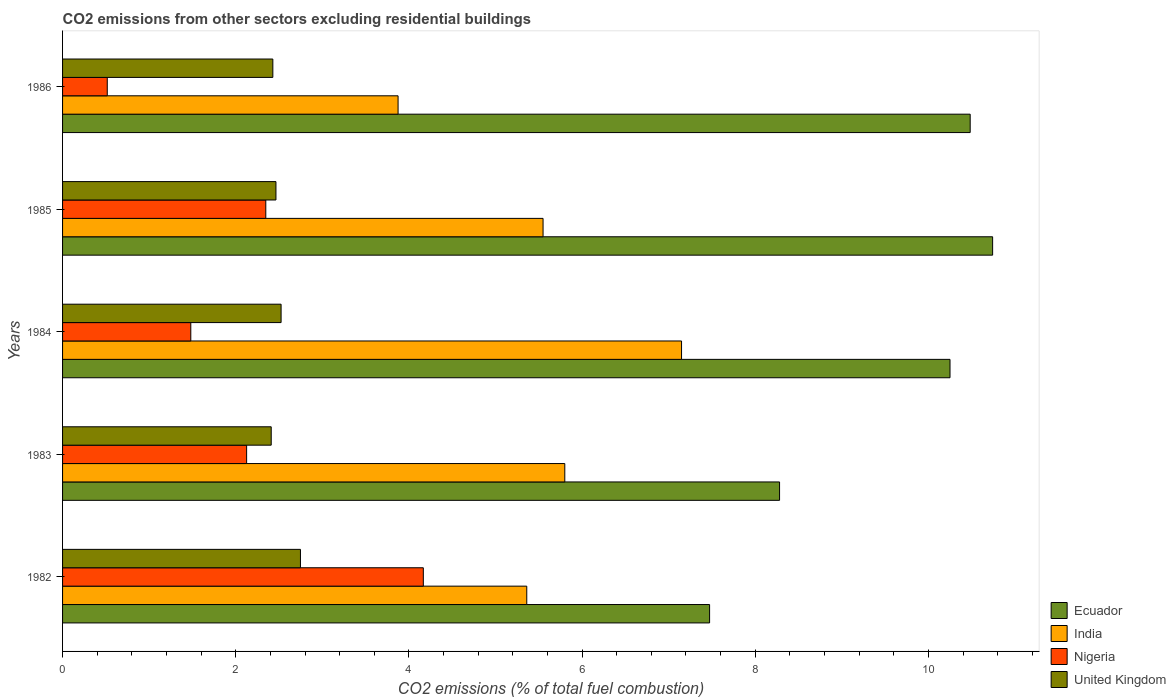How many groups of bars are there?
Offer a very short reply. 5. Are the number of bars per tick equal to the number of legend labels?
Give a very brief answer. Yes. In how many cases, is the number of bars for a given year not equal to the number of legend labels?
Ensure brevity in your answer.  0. What is the total CO2 emitted in United Kingdom in 1986?
Offer a very short reply. 2.43. Across all years, what is the maximum total CO2 emitted in Nigeria?
Offer a very short reply. 4.17. Across all years, what is the minimum total CO2 emitted in Ecuador?
Provide a succinct answer. 7.47. In which year was the total CO2 emitted in Ecuador minimum?
Offer a very short reply. 1982. What is the total total CO2 emitted in United Kingdom in the graph?
Make the answer very short. 12.57. What is the difference between the total CO2 emitted in India in 1983 and that in 1985?
Make the answer very short. 0.25. What is the difference between the total CO2 emitted in Nigeria in 1985 and the total CO2 emitted in India in 1984?
Your answer should be compact. -4.8. What is the average total CO2 emitted in Nigeria per year?
Provide a short and direct response. 2.13. In the year 1985, what is the difference between the total CO2 emitted in Ecuador and total CO2 emitted in India?
Offer a terse response. 5.19. What is the ratio of the total CO2 emitted in Ecuador in 1982 to that in 1986?
Your response must be concise. 0.71. Is the difference between the total CO2 emitted in Ecuador in 1984 and 1986 greater than the difference between the total CO2 emitted in India in 1984 and 1986?
Make the answer very short. No. What is the difference between the highest and the second highest total CO2 emitted in India?
Your answer should be compact. 1.35. What is the difference between the highest and the lowest total CO2 emitted in United Kingdom?
Provide a succinct answer. 0.34. Is the sum of the total CO2 emitted in Ecuador in 1982 and 1984 greater than the maximum total CO2 emitted in India across all years?
Your answer should be very brief. Yes. Is it the case that in every year, the sum of the total CO2 emitted in Ecuador and total CO2 emitted in United Kingdom is greater than the sum of total CO2 emitted in Nigeria and total CO2 emitted in India?
Offer a terse response. No. What does the 3rd bar from the bottom in 1985 represents?
Your answer should be very brief. Nigeria. Is it the case that in every year, the sum of the total CO2 emitted in India and total CO2 emitted in Ecuador is greater than the total CO2 emitted in Nigeria?
Offer a terse response. Yes. How many bars are there?
Your answer should be very brief. 20. Are all the bars in the graph horizontal?
Offer a very short reply. Yes. Does the graph contain any zero values?
Provide a short and direct response. No. Does the graph contain grids?
Offer a terse response. No. Where does the legend appear in the graph?
Provide a succinct answer. Bottom right. How many legend labels are there?
Offer a terse response. 4. How are the legend labels stacked?
Offer a very short reply. Vertical. What is the title of the graph?
Make the answer very short. CO2 emissions from other sectors excluding residential buildings. Does "Korea (Democratic)" appear as one of the legend labels in the graph?
Your answer should be very brief. No. What is the label or title of the X-axis?
Give a very brief answer. CO2 emissions (% of total fuel combustion). What is the CO2 emissions (% of total fuel combustion) of Ecuador in 1982?
Provide a succinct answer. 7.47. What is the CO2 emissions (% of total fuel combustion) of India in 1982?
Your answer should be very brief. 5.36. What is the CO2 emissions (% of total fuel combustion) in Nigeria in 1982?
Offer a terse response. 4.17. What is the CO2 emissions (% of total fuel combustion) of United Kingdom in 1982?
Your answer should be compact. 2.75. What is the CO2 emissions (% of total fuel combustion) of Ecuador in 1983?
Provide a short and direct response. 8.28. What is the CO2 emissions (% of total fuel combustion) of India in 1983?
Make the answer very short. 5.8. What is the CO2 emissions (% of total fuel combustion) of Nigeria in 1983?
Keep it short and to the point. 2.13. What is the CO2 emissions (% of total fuel combustion) of United Kingdom in 1983?
Ensure brevity in your answer.  2.41. What is the CO2 emissions (% of total fuel combustion) of Ecuador in 1984?
Your answer should be very brief. 10.25. What is the CO2 emissions (% of total fuel combustion) of India in 1984?
Offer a very short reply. 7.15. What is the CO2 emissions (% of total fuel combustion) of Nigeria in 1984?
Provide a succinct answer. 1.48. What is the CO2 emissions (% of total fuel combustion) of United Kingdom in 1984?
Keep it short and to the point. 2.52. What is the CO2 emissions (% of total fuel combustion) in Ecuador in 1985?
Your answer should be compact. 10.74. What is the CO2 emissions (% of total fuel combustion) of India in 1985?
Your response must be concise. 5.55. What is the CO2 emissions (% of total fuel combustion) in Nigeria in 1985?
Your response must be concise. 2.35. What is the CO2 emissions (% of total fuel combustion) in United Kingdom in 1985?
Your answer should be very brief. 2.46. What is the CO2 emissions (% of total fuel combustion) of Ecuador in 1986?
Give a very brief answer. 10.48. What is the CO2 emissions (% of total fuel combustion) of India in 1986?
Make the answer very short. 3.88. What is the CO2 emissions (% of total fuel combustion) of Nigeria in 1986?
Keep it short and to the point. 0.52. What is the CO2 emissions (% of total fuel combustion) in United Kingdom in 1986?
Make the answer very short. 2.43. Across all years, what is the maximum CO2 emissions (% of total fuel combustion) of Ecuador?
Your answer should be very brief. 10.74. Across all years, what is the maximum CO2 emissions (% of total fuel combustion) of India?
Make the answer very short. 7.15. Across all years, what is the maximum CO2 emissions (% of total fuel combustion) in Nigeria?
Your answer should be compact. 4.17. Across all years, what is the maximum CO2 emissions (% of total fuel combustion) in United Kingdom?
Give a very brief answer. 2.75. Across all years, what is the minimum CO2 emissions (% of total fuel combustion) in Ecuador?
Ensure brevity in your answer.  7.47. Across all years, what is the minimum CO2 emissions (% of total fuel combustion) of India?
Your answer should be compact. 3.88. Across all years, what is the minimum CO2 emissions (% of total fuel combustion) of Nigeria?
Ensure brevity in your answer.  0.52. Across all years, what is the minimum CO2 emissions (% of total fuel combustion) of United Kingdom?
Offer a terse response. 2.41. What is the total CO2 emissions (% of total fuel combustion) in Ecuador in the graph?
Offer a terse response. 47.23. What is the total CO2 emissions (% of total fuel combustion) in India in the graph?
Your response must be concise. 27.73. What is the total CO2 emissions (% of total fuel combustion) of Nigeria in the graph?
Offer a very short reply. 10.64. What is the total CO2 emissions (% of total fuel combustion) in United Kingdom in the graph?
Your answer should be very brief. 12.57. What is the difference between the CO2 emissions (% of total fuel combustion) in Ecuador in 1982 and that in 1983?
Offer a terse response. -0.81. What is the difference between the CO2 emissions (% of total fuel combustion) in India in 1982 and that in 1983?
Offer a very short reply. -0.44. What is the difference between the CO2 emissions (% of total fuel combustion) of Nigeria in 1982 and that in 1983?
Your answer should be compact. 2.04. What is the difference between the CO2 emissions (% of total fuel combustion) of United Kingdom in 1982 and that in 1983?
Your response must be concise. 0.34. What is the difference between the CO2 emissions (% of total fuel combustion) of Ecuador in 1982 and that in 1984?
Offer a very short reply. -2.78. What is the difference between the CO2 emissions (% of total fuel combustion) in India in 1982 and that in 1984?
Ensure brevity in your answer.  -1.79. What is the difference between the CO2 emissions (% of total fuel combustion) in Nigeria in 1982 and that in 1984?
Ensure brevity in your answer.  2.69. What is the difference between the CO2 emissions (% of total fuel combustion) of United Kingdom in 1982 and that in 1984?
Your answer should be very brief. 0.22. What is the difference between the CO2 emissions (% of total fuel combustion) in Ecuador in 1982 and that in 1985?
Give a very brief answer. -3.27. What is the difference between the CO2 emissions (% of total fuel combustion) in India in 1982 and that in 1985?
Offer a very short reply. -0.19. What is the difference between the CO2 emissions (% of total fuel combustion) of Nigeria in 1982 and that in 1985?
Your answer should be compact. 1.82. What is the difference between the CO2 emissions (% of total fuel combustion) in United Kingdom in 1982 and that in 1985?
Keep it short and to the point. 0.28. What is the difference between the CO2 emissions (% of total fuel combustion) of Ecuador in 1982 and that in 1986?
Keep it short and to the point. -3.01. What is the difference between the CO2 emissions (% of total fuel combustion) in India in 1982 and that in 1986?
Offer a very short reply. 1.49. What is the difference between the CO2 emissions (% of total fuel combustion) in Nigeria in 1982 and that in 1986?
Provide a short and direct response. 3.65. What is the difference between the CO2 emissions (% of total fuel combustion) of United Kingdom in 1982 and that in 1986?
Give a very brief answer. 0.32. What is the difference between the CO2 emissions (% of total fuel combustion) of Ecuador in 1983 and that in 1984?
Your answer should be very brief. -1.97. What is the difference between the CO2 emissions (% of total fuel combustion) of India in 1983 and that in 1984?
Ensure brevity in your answer.  -1.35. What is the difference between the CO2 emissions (% of total fuel combustion) in Nigeria in 1983 and that in 1984?
Offer a very short reply. 0.64. What is the difference between the CO2 emissions (% of total fuel combustion) in United Kingdom in 1983 and that in 1984?
Offer a very short reply. -0.11. What is the difference between the CO2 emissions (% of total fuel combustion) in Ecuador in 1983 and that in 1985?
Keep it short and to the point. -2.46. What is the difference between the CO2 emissions (% of total fuel combustion) in India in 1983 and that in 1985?
Provide a short and direct response. 0.25. What is the difference between the CO2 emissions (% of total fuel combustion) of Nigeria in 1983 and that in 1985?
Your response must be concise. -0.22. What is the difference between the CO2 emissions (% of total fuel combustion) in United Kingdom in 1983 and that in 1985?
Your answer should be compact. -0.05. What is the difference between the CO2 emissions (% of total fuel combustion) of Ecuador in 1983 and that in 1986?
Give a very brief answer. -2.2. What is the difference between the CO2 emissions (% of total fuel combustion) of India in 1983 and that in 1986?
Your response must be concise. 1.93. What is the difference between the CO2 emissions (% of total fuel combustion) of Nigeria in 1983 and that in 1986?
Make the answer very short. 1.61. What is the difference between the CO2 emissions (% of total fuel combustion) of United Kingdom in 1983 and that in 1986?
Your response must be concise. -0.02. What is the difference between the CO2 emissions (% of total fuel combustion) in Ecuador in 1984 and that in 1985?
Provide a succinct answer. -0.49. What is the difference between the CO2 emissions (% of total fuel combustion) in India in 1984 and that in 1985?
Keep it short and to the point. 1.6. What is the difference between the CO2 emissions (% of total fuel combustion) in Nigeria in 1984 and that in 1985?
Your answer should be compact. -0.87. What is the difference between the CO2 emissions (% of total fuel combustion) of United Kingdom in 1984 and that in 1985?
Give a very brief answer. 0.06. What is the difference between the CO2 emissions (% of total fuel combustion) of Ecuador in 1984 and that in 1986?
Ensure brevity in your answer.  -0.23. What is the difference between the CO2 emissions (% of total fuel combustion) of India in 1984 and that in 1986?
Provide a short and direct response. 3.27. What is the difference between the CO2 emissions (% of total fuel combustion) in Nigeria in 1984 and that in 1986?
Ensure brevity in your answer.  0.96. What is the difference between the CO2 emissions (% of total fuel combustion) of United Kingdom in 1984 and that in 1986?
Your answer should be compact. 0.1. What is the difference between the CO2 emissions (% of total fuel combustion) in Ecuador in 1985 and that in 1986?
Keep it short and to the point. 0.26. What is the difference between the CO2 emissions (% of total fuel combustion) in India in 1985 and that in 1986?
Your answer should be compact. 1.67. What is the difference between the CO2 emissions (% of total fuel combustion) in Nigeria in 1985 and that in 1986?
Offer a terse response. 1.83. What is the difference between the CO2 emissions (% of total fuel combustion) of United Kingdom in 1985 and that in 1986?
Give a very brief answer. 0.04. What is the difference between the CO2 emissions (% of total fuel combustion) in Ecuador in 1982 and the CO2 emissions (% of total fuel combustion) in India in 1983?
Keep it short and to the point. 1.67. What is the difference between the CO2 emissions (% of total fuel combustion) of Ecuador in 1982 and the CO2 emissions (% of total fuel combustion) of Nigeria in 1983?
Provide a succinct answer. 5.35. What is the difference between the CO2 emissions (% of total fuel combustion) of Ecuador in 1982 and the CO2 emissions (% of total fuel combustion) of United Kingdom in 1983?
Keep it short and to the point. 5.06. What is the difference between the CO2 emissions (% of total fuel combustion) of India in 1982 and the CO2 emissions (% of total fuel combustion) of Nigeria in 1983?
Keep it short and to the point. 3.24. What is the difference between the CO2 emissions (% of total fuel combustion) in India in 1982 and the CO2 emissions (% of total fuel combustion) in United Kingdom in 1983?
Provide a short and direct response. 2.95. What is the difference between the CO2 emissions (% of total fuel combustion) of Nigeria in 1982 and the CO2 emissions (% of total fuel combustion) of United Kingdom in 1983?
Offer a terse response. 1.76. What is the difference between the CO2 emissions (% of total fuel combustion) of Ecuador in 1982 and the CO2 emissions (% of total fuel combustion) of India in 1984?
Give a very brief answer. 0.32. What is the difference between the CO2 emissions (% of total fuel combustion) of Ecuador in 1982 and the CO2 emissions (% of total fuel combustion) of Nigeria in 1984?
Your response must be concise. 5.99. What is the difference between the CO2 emissions (% of total fuel combustion) in Ecuador in 1982 and the CO2 emissions (% of total fuel combustion) in United Kingdom in 1984?
Keep it short and to the point. 4.95. What is the difference between the CO2 emissions (% of total fuel combustion) of India in 1982 and the CO2 emissions (% of total fuel combustion) of Nigeria in 1984?
Your answer should be very brief. 3.88. What is the difference between the CO2 emissions (% of total fuel combustion) of India in 1982 and the CO2 emissions (% of total fuel combustion) of United Kingdom in 1984?
Give a very brief answer. 2.84. What is the difference between the CO2 emissions (% of total fuel combustion) in Nigeria in 1982 and the CO2 emissions (% of total fuel combustion) in United Kingdom in 1984?
Offer a very short reply. 1.64. What is the difference between the CO2 emissions (% of total fuel combustion) in Ecuador in 1982 and the CO2 emissions (% of total fuel combustion) in India in 1985?
Offer a terse response. 1.92. What is the difference between the CO2 emissions (% of total fuel combustion) of Ecuador in 1982 and the CO2 emissions (% of total fuel combustion) of Nigeria in 1985?
Your response must be concise. 5.13. What is the difference between the CO2 emissions (% of total fuel combustion) of Ecuador in 1982 and the CO2 emissions (% of total fuel combustion) of United Kingdom in 1985?
Give a very brief answer. 5.01. What is the difference between the CO2 emissions (% of total fuel combustion) in India in 1982 and the CO2 emissions (% of total fuel combustion) in Nigeria in 1985?
Your response must be concise. 3.01. What is the difference between the CO2 emissions (% of total fuel combustion) of India in 1982 and the CO2 emissions (% of total fuel combustion) of United Kingdom in 1985?
Offer a terse response. 2.9. What is the difference between the CO2 emissions (% of total fuel combustion) of Nigeria in 1982 and the CO2 emissions (% of total fuel combustion) of United Kingdom in 1985?
Make the answer very short. 1.7. What is the difference between the CO2 emissions (% of total fuel combustion) in Ecuador in 1982 and the CO2 emissions (% of total fuel combustion) in India in 1986?
Give a very brief answer. 3.6. What is the difference between the CO2 emissions (% of total fuel combustion) of Ecuador in 1982 and the CO2 emissions (% of total fuel combustion) of Nigeria in 1986?
Provide a short and direct response. 6.96. What is the difference between the CO2 emissions (% of total fuel combustion) in Ecuador in 1982 and the CO2 emissions (% of total fuel combustion) in United Kingdom in 1986?
Ensure brevity in your answer.  5.04. What is the difference between the CO2 emissions (% of total fuel combustion) of India in 1982 and the CO2 emissions (% of total fuel combustion) of Nigeria in 1986?
Offer a terse response. 4.84. What is the difference between the CO2 emissions (% of total fuel combustion) in India in 1982 and the CO2 emissions (% of total fuel combustion) in United Kingdom in 1986?
Offer a very short reply. 2.93. What is the difference between the CO2 emissions (% of total fuel combustion) in Nigeria in 1982 and the CO2 emissions (% of total fuel combustion) in United Kingdom in 1986?
Offer a very short reply. 1.74. What is the difference between the CO2 emissions (% of total fuel combustion) in Ecuador in 1983 and the CO2 emissions (% of total fuel combustion) in India in 1984?
Give a very brief answer. 1.13. What is the difference between the CO2 emissions (% of total fuel combustion) in Ecuador in 1983 and the CO2 emissions (% of total fuel combustion) in Nigeria in 1984?
Your response must be concise. 6.8. What is the difference between the CO2 emissions (% of total fuel combustion) of Ecuador in 1983 and the CO2 emissions (% of total fuel combustion) of United Kingdom in 1984?
Provide a succinct answer. 5.76. What is the difference between the CO2 emissions (% of total fuel combustion) in India in 1983 and the CO2 emissions (% of total fuel combustion) in Nigeria in 1984?
Your response must be concise. 4.32. What is the difference between the CO2 emissions (% of total fuel combustion) of India in 1983 and the CO2 emissions (% of total fuel combustion) of United Kingdom in 1984?
Your answer should be very brief. 3.28. What is the difference between the CO2 emissions (% of total fuel combustion) in Nigeria in 1983 and the CO2 emissions (% of total fuel combustion) in United Kingdom in 1984?
Offer a very short reply. -0.4. What is the difference between the CO2 emissions (% of total fuel combustion) in Ecuador in 1983 and the CO2 emissions (% of total fuel combustion) in India in 1985?
Provide a succinct answer. 2.73. What is the difference between the CO2 emissions (% of total fuel combustion) in Ecuador in 1983 and the CO2 emissions (% of total fuel combustion) in Nigeria in 1985?
Your answer should be very brief. 5.93. What is the difference between the CO2 emissions (% of total fuel combustion) in Ecuador in 1983 and the CO2 emissions (% of total fuel combustion) in United Kingdom in 1985?
Give a very brief answer. 5.82. What is the difference between the CO2 emissions (% of total fuel combustion) in India in 1983 and the CO2 emissions (% of total fuel combustion) in Nigeria in 1985?
Offer a very short reply. 3.45. What is the difference between the CO2 emissions (% of total fuel combustion) in India in 1983 and the CO2 emissions (% of total fuel combustion) in United Kingdom in 1985?
Provide a short and direct response. 3.34. What is the difference between the CO2 emissions (% of total fuel combustion) in Nigeria in 1983 and the CO2 emissions (% of total fuel combustion) in United Kingdom in 1985?
Your answer should be compact. -0.34. What is the difference between the CO2 emissions (% of total fuel combustion) in Ecuador in 1983 and the CO2 emissions (% of total fuel combustion) in India in 1986?
Your answer should be very brief. 4.41. What is the difference between the CO2 emissions (% of total fuel combustion) in Ecuador in 1983 and the CO2 emissions (% of total fuel combustion) in Nigeria in 1986?
Provide a short and direct response. 7.76. What is the difference between the CO2 emissions (% of total fuel combustion) of Ecuador in 1983 and the CO2 emissions (% of total fuel combustion) of United Kingdom in 1986?
Give a very brief answer. 5.85. What is the difference between the CO2 emissions (% of total fuel combustion) of India in 1983 and the CO2 emissions (% of total fuel combustion) of Nigeria in 1986?
Provide a short and direct response. 5.28. What is the difference between the CO2 emissions (% of total fuel combustion) in India in 1983 and the CO2 emissions (% of total fuel combustion) in United Kingdom in 1986?
Offer a terse response. 3.37. What is the difference between the CO2 emissions (% of total fuel combustion) of Nigeria in 1983 and the CO2 emissions (% of total fuel combustion) of United Kingdom in 1986?
Give a very brief answer. -0.3. What is the difference between the CO2 emissions (% of total fuel combustion) in Ecuador in 1984 and the CO2 emissions (% of total fuel combustion) in India in 1985?
Your answer should be very brief. 4.7. What is the difference between the CO2 emissions (% of total fuel combustion) of Ecuador in 1984 and the CO2 emissions (% of total fuel combustion) of Nigeria in 1985?
Keep it short and to the point. 7.9. What is the difference between the CO2 emissions (% of total fuel combustion) in Ecuador in 1984 and the CO2 emissions (% of total fuel combustion) in United Kingdom in 1985?
Your response must be concise. 7.79. What is the difference between the CO2 emissions (% of total fuel combustion) in India in 1984 and the CO2 emissions (% of total fuel combustion) in Nigeria in 1985?
Offer a terse response. 4.8. What is the difference between the CO2 emissions (% of total fuel combustion) in India in 1984 and the CO2 emissions (% of total fuel combustion) in United Kingdom in 1985?
Your response must be concise. 4.68. What is the difference between the CO2 emissions (% of total fuel combustion) of Nigeria in 1984 and the CO2 emissions (% of total fuel combustion) of United Kingdom in 1985?
Your answer should be very brief. -0.98. What is the difference between the CO2 emissions (% of total fuel combustion) of Ecuador in 1984 and the CO2 emissions (% of total fuel combustion) of India in 1986?
Your answer should be compact. 6.37. What is the difference between the CO2 emissions (% of total fuel combustion) in Ecuador in 1984 and the CO2 emissions (% of total fuel combustion) in Nigeria in 1986?
Provide a short and direct response. 9.73. What is the difference between the CO2 emissions (% of total fuel combustion) in Ecuador in 1984 and the CO2 emissions (% of total fuel combustion) in United Kingdom in 1986?
Provide a succinct answer. 7.82. What is the difference between the CO2 emissions (% of total fuel combustion) of India in 1984 and the CO2 emissions (% of total fuel combustion) of Nigeria in 1986?
Keep it short and to the point. 6.63. What is the difference between the CO2 emissions (% of total fuel combustion) in India in 1984 and the CO2 emissions (% of total fuel combustion) in United Kingdom in 1986?
Provide a short and direct response. 4.72. What is the difference between the CO2 emissions (% of total fuel combustion) in Nigeria in 1984 and the CO2 emissions (% of total fuel combustion) in United Kingdom in 1986?
Make the answer very short. -0.95. What is the difference between the CO2 emissions (% of total fuel combustion) in Ecuador in 1985 and the CO2 emissions (% of total fuel combustion) in India in 1986?
Offer a terse response. 6.87. What is the difference between the CO2 emissions (% of total fuel combustion) in Ecuador in 1985 and the CO2 emissions (% of total fuel combustion) in Nigeria in 1986?
Ensure brevity in your answer.  10.23. What is the difference between the CO2 emissions (% of total fuel combustion) of Ecuador in 1985 and the CO2 emissions (% of total fuel combustion) of United Kingdom in 1986?
Offer a terse response. 8.31. What is the difference between the CO2 emissions (% of total fuel combustion) of India in 1985 and the CO2 emissions (% of total fuel combustion) of Nigeria in 1986?
Your answer should be compact. 5.03. What is the difference between the CO2 emissions (% of total fuel combustion) of India in 1985 and the CO2 emissions (% of total fuel combustion) of United Kingdom in 1986?
Offer a terse response. 3.12. What is the difference between the CO2 emissions (% of total fuel combustion) in Nigeria in 1985 and the CO2 emissions (% of total fuel combustion) in United Kingdom in 1986?
Your answer should be compact. -0.08. What is the average CO2 emissions (% of total fuel combustion) of Ecuador per year?
Offer a very short reply. 9.45. What is the average CO2 emissions (% of total fuel combustion) of India per year?
Your answer should be compact. 5.55. What is the average CO2 emissions (% of total fuel combustion) in Nigeria per year?
Keep it short and to the point. 2.13. What is the average CO2 emissions (% of total fuel combustion) of United Kingdom per year?
Provide a short and direct response. 2.51. In the year 1982, what is the difference between the CO2 emissions (% of total fuel combustion) of Ecuador and CO2 emissions (% of total fuel combustion) of India?
Give a very brief answer. 2.11. In the year 1982, what is the difference between the CO2 emissions (% of total fuel combustion) of Ecuador and CO2 emissions (% of total fuel combustion) of Nigeria?
Give a very brief answer. 3.31. In the year 1982, what is the difference between the CO2 emissions (% of total fuel combustion) of Ecuador and CO2 emissions (% of total fuel combustion) of United Kingdom?
Provide a succinct answer. 4.73. In the year 1982, what is the difference between the CO2 emissions (% of total fuel combustion) of India and CO2 emissions (% of total fuel combustion) of Nigeria?
Offer a terse response. 1.19. In the year 1982, what is the difference between the CO2 emissions (% of total fuel combustion) of India and CO2 emissions (% of total fuel combustion) of United Kingdom?
Offer a very short reply. 2.61. In the year 1982, what is the difference between the CO2 emissions (% of total fuel combustion) of Nigeria and CO2 emissions (% of total fuel combustion) of United Kingdom?
Give a very brief answer. 1.42. In the year 1983, what is the difference between the CO2 emissions (% of total fuel combustion) in Ecuador and CO2 emissions (% of total fuel combustion) in India?
Make the answer very short. 2.48. In the year 1983, what is the difference between the CO2 emissions (% of total fuel combustion) of Ecuador and CO2 emissions (% of total fuel combustion) of Nigeria?
Offer a terse response. 6.16. In the year 1983, what is the difference between the CO2 emissions (% of total fuel combustion) in Ecuador and CO2 emissions (% of total fuel combustion) in United Kingdom?
Ensure brevity in your answer.  5.87. In the year 1983, what is the difference between the CO2 emissions (% of total fuel combustion) in India and CO2 emissions (% of total fuel combustion) in Nigeria?
Provide a short and direct response. 3.67. In the year 1983, what is the difference between the CO2 emissions (% of total fuel combustion) in India and CO2 emissions (% of total fuel combustion) in United Kingdom?
Provide a succinct answer. 3.39. In the year 1983, what is the difference between the CO2 emissions (% of total fuel combustion) of Nigeria and CO2 emissions (% of total fuel combustion) of United Kingdom?
Offer a terse response. -0.28. In the year 1984, what is the difference between the CO2 emissions (% of total fuel combustion) in Ecuador and CO2 emissions (% of total fuel combustion) in India?
Ensure brevity in your answer.  3.1. In the year 1984, what is the difference between the CO2 emissions (% of total fuel combustion) of Ecuador and CO2 emissions (% of total fuel combustion) of Nigeria?
Provide a short and direct response. 8.77. In the year 1984, what is the difference between the CO2 emissions (% of total fuel combustion) in Ecuador and CO2 emissions (% of total fuel combustion) in United Kingdom?
Your response must be concise. 7.73. In the year 1984, what is the difference between the CO2 emissions (% of total fuel combustion) in India and CO2 emissions (% of total fuel combustion) in Nigeria?
Keep it short and to the point. 5.67. In the year 1984, what is the difference between the CO2 emissions (% of total fuel combustion) in India and CO2 emissions (% of total fuel combustion) in United Kingdom?
Keep it short and to the point. 4.62. In the year 1984, what is the difference between the CO2 emissions (% of total fuel combustion) in Nigeria and CO2 emissions (% of total fuel combustion) in United Kingdom?
Make the answer very short. -1.04. In the year 1985, what is the difference between the CO2 emissions (% of total fuel combustion) in Ecuador and CO2 emissions (% of total fuel combustion) in India?
Give a very brief answer. 5.19. In the year 1985, what is the difference between the CO2 emissions (% of total fuel combustion) in Ecuador and CO2 emissions (% of total fuel combustion) in Nigeria?
Keep it short and to the point. 8.39. In the year 1985, what is the difference between the CO2 emissions (% of total fuel combustion) in Ecuador and CO2 emissions (% of total fuel combustion) in United Kingdom?
Keep it short and to the point. 8.28. In the year 1985, what is the difference between the CO2 emissions (% of total fuel combustion) of India and CO2 emissions (% of total fuel combustion) of Nigeria?
Offer a very short reply. 3.2. In the year 1985, what is the difference between the CO2 emissions (% of total fuel combustion) of India and CO2 emissions (% of total fuel combustion) of United Kingdom?
Ensure brevity in your answer.  3.08. In the year 1985, what is the difference between the CO2 emissions (% of total fuel combustion) of Nigeria and CO2 emissions (% of total fuel combustion) of United Kingdom?
Your response must be concise. -0.12. In the year 1986, what is the difference between the CO2 emissions (% of total fuel combustion) in Ecuador and CO2 emissions (% of total fuel combustion) in India?
Your answer should be very brief. 6.61. In the year 1986, what is the difference between the CO2 emissions (% of total fuel combustion) of Ecuador and CO2 emissions (% of total fuel combustion) of Nigeria?
Your response must be concise. 9.97. In the year 1986, what is the difference between the CO2 emissions (% of total fuel combustion) of Ecuador and CO2 emissions (% of total fuel combustion) of United Kingdom?
Offer a very short reply. 8.05. In the year 1986, what is the difference between the CO2 emissions (% of total fuel combustion) of India and CO2 emissions (% of total fuel combustion) of Nigeria?
Ensure brevity in your answer.  3.36. In the year 1986, what is the difference between the CO2 emissions (% of total fuel combustion) in India and CO2 emissions (% of total fuel combustion) in United Kingdom?
Your response must be concise. 1.45. In the year 1986, what is the difference between the CO2 emissions (% of total fuel combustion) of Nigeria and CO2 emissions (% of total fuel combustion) of United Kingdom?
Ensure brevity in your answer.  -1.91. What is the ratio of the CO2 emissions (% of total fuel combustion) in Ecuador in 1982 to that in 1983?
Your answer should be very brief. 0.9. What is the ratio of the CO2 emissions (% of total fuel combustion) of India in 1982 to that in 1983?
Keep it short and to the point. 0.92. What is the ratio of the CO2 emissions (% of total fuel combustion) of Nigeria in 1982 to that in 1983?
Your answer should be compact. 1.96. What is the ratio of the CO2 emissions (% of total fuel combustion) of United Kingdom in 1982 to that in 1983?
Your answer should be very brief. 1.14. What is the ratio of the CO2 emissions (% of total fuel combustion) of Ecuador in 1982 to that in 1984?
Make the answer very short. 0.73. What is the ratio of the CO2 emissions (% of total fuel combustion) of India in 1982 to that in 1984?
Offer a terse response. 0.75. What is the ratio of the CO2 emissions (% of total fuel combustion) of Nigeria in 1982 to that in 1984?
Your response must be concise. 2.81. What is the ratio of the CO2 emissions (% of total fuel combustion) in United Kingdom in 1982 to that in 1984?
Make the answer very short. 1.09. What is the ratio of the CO2 emissions (% of total fuel combustion) in Ecuador in 1982 to that in 1985?
Ensure brevity in your answer.  0.7. What is the ratio of the CO2 emissions (% of total fuel combustion) of India in 1982 to that in 1985?
Make the answer very short. 0.97. What is the ratio of the CO2 emissions (% of total fuel combustion) of Nigeria in 1982 to that in 1985?
Offer a very short reply. 1.78. What is the ratio of the CO2 emissions (% of total fuel combustion) of United Kingdom in 1982 to that in 1985?
Offer a very short reply. 1.11. What is the ratio of the CO2 emissions (% of total fuel combustion) of Ecuador in 1982 to that in 1986?
Make the answer very short. 0.71. What is the ratio of the CO2 emissions (% of total fuel combustion) in India in 1982 to that in 1986?
Make the answer very short. 1.38. What is the ratio of the CO2 emissions (% of total fuel combustion) of Nigeria in 1982 to that in 1986?
Offer a terse response. 8.07. What is the ratio of the CO2 emissions (% of total fuel combustion) in United Kingdom in 1982 to that in 1986?
Keep it short and to the point. 1.13. What is the ratio of the CO2 emissions (% of total fuel combustion) in Ecuador in 1983 to that in 1984?
Keep it short and to the point. 0.81. What is the ratio of the CO2 emissions (% of total fuel combustion) in India in 1983 to that in 1984?
Ensure brevity in your answer.  0.81. What is the ratio of the CO2 emissions (% of total fuel combustion) of Nigeria in 1983 to that in 1984?
Your answer should be compact. 1.44. What is the ratio of the CO2 emissions (% of total fuel combustion) of United Kingdom in 1983 to that in 1984?
Provide a short and direct response. 0.95. What is the ratio of the CO2 emissions (% of total fuel combustion) of Ecuador in 1983 to that in 1985?
Your response must be concise. 0.77. What is the ratio of the CO2 emissions (% of total fuel combustion) of India in 1983 to that in 1985?
Make the answer very short. 1.05. What is the ratio of the CO2 emissions (% of total fuel combustion) in Nigeria in 1983 to that in 1985?
Provide a short and direct response. 0.91. What is the ratio of the CO2 emissions (% of total fuel combustion) of United Kingdom in 1983 to that in 1985?
Make the answer very short. 0.98. What is the ratio of the CO2 emissions (% of total fuel combustion) of Ecuador in 1983 to that in 1986?
Make the answer very short. 0.79. What is the ratio of the CO2 emissions (% of total fuel combustion) of India in 1983 to that in 1986?
Give a very brief answer. 1.5. What is the ratio of the CO2 emissions (% of total fuel combustion) in Nigeria in 1983 to that in 1986?
Your answer should be compact. 4.12. What is the ratio of the CO2 emissions (% of total fuel combustion) of Ecuador in 1984 to that in 1985?
Offer a terse response. 0.95. What is the ratio of the CO2 emissions (% of total fuel combustion) in India in 1984 to that in 1985?
Offer a terse response. 1.29. What is the ratio of the CO2 emissions (% of total fuel combustion) in Nigeria in 1984 to that in 1985?
Provide a succinct answer. 0.63. What is the ratio of the CO2 emissions (% of total fuel combustion) in United Kingdom in 1984 to that in 1985?
Your answer should be compact. 1.02. What is the ratio of the CO2 emissions (% of total fuel combustion) of Ecuador in 1984 to that in 1986?
Your answer should be very brief. 0.98. What is the ratio of the CO2 emissions (% of total fuel combustion) in India in 1984 to that in 1986?
Give a very brief answer. 1.84. What is the ratio of the CO2 emissions (% of total fuel combustion) in Nigeria in 1984 to that in 1986?
Keep it short and to the point. 2.87. What is the ratio of the CO2 emissions (% of total fuel combustion) in United Kingdom in 1984 to that in 1986?
Your answer should be very brief. 1.04. What is the ratio of the CO2 emissions (% of total fuel combustion) in Ecuador in 1985 to that in 1986?
Keep it short and to the point. 1.02. What is the ratio of the CO2 emissions (% of total fuel combustion) in India in 1985 to that in 1986?
Give a very brief answer. 1.43. What is the ratio of the CO2 emissions (% of total fuel combustion) of Nigeria in 1985 to that in 1986?
Keep it short and to the point. 4.55. What is the ratio of the CO2 emissions (% of total fuel combustion) in United Kingdom in 1985 to that in 1986?
Make the answer very short. 1.01. What is the difference between the highest and the second highest CO2 emissions (% of total fuel combustion) in Ecuador?
Your answer should be very brief. 0.26. What is the difference between the highest and the second highest CO2 emissions (% of total fuel combustion) of India?
Offer a very short reply. 1.35. What is the difference between the highest and the second highest CO2 emissions (% of total fuel combustion) of Nigeria?
Give a very brief answer. 1.82. What is the difference between the highest and the second highest CO2 emissions (% of total fuel combustion) of United Kingdom?
Offer a terse response. 0.22. What is the difference between the highest and the lowest CO2 emissions (% of total fuel combustion) of Ecuador?
Provide a short and direct response. 3.27. What is the difference between the highest and the lowest CO2 emissions (% of total fuel combustion) of India?
Make the answer very short. 3.27. What is the difference between the highest and the lowest CO2 emissions (% of total fuel combustion) in Nigeria?
Your response must be concise. 3.65. What is the difference between the highest and the lowest CO2 emissions (% of total fuel combustion) of United Kingdom?
Offer a terse response. 0.34. 